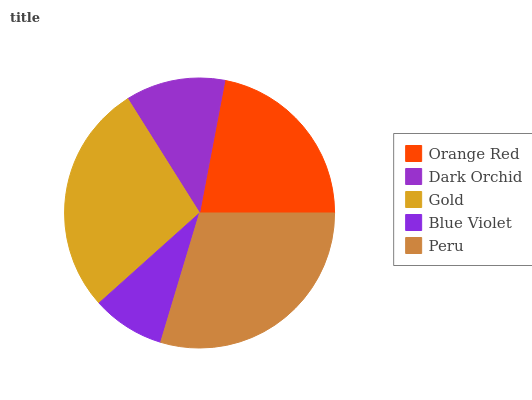Is Blue Violet the minimum?
Answer yes or no. Yes. Is Peru the maximum?
Answer yes or no. Yes. Is Dark Orchid the minimum?
Answer yes or no. No. Is Dark Orchid the maximum?
Answer yes or no. No. Is Orange Red greater than Dark Orchid?
Answer yes or no. Yes. Is Dark Orchid less than Orange Red?
Answer yes or no. Yes. Is Dark Orchid greater than Orange Red?
Answer yes or no. No. Is Orange Red less than Dark Orchid?
Answer yes or no. No. Is Orange Red the high median?
Answer yes or no. Yes. Is Orange Red the low median?
Answer yes or no. Yes. Is Dark Orchid the high median?
Answer yes or no. No. Is Gold the low median?
Answer yes or no. No. 